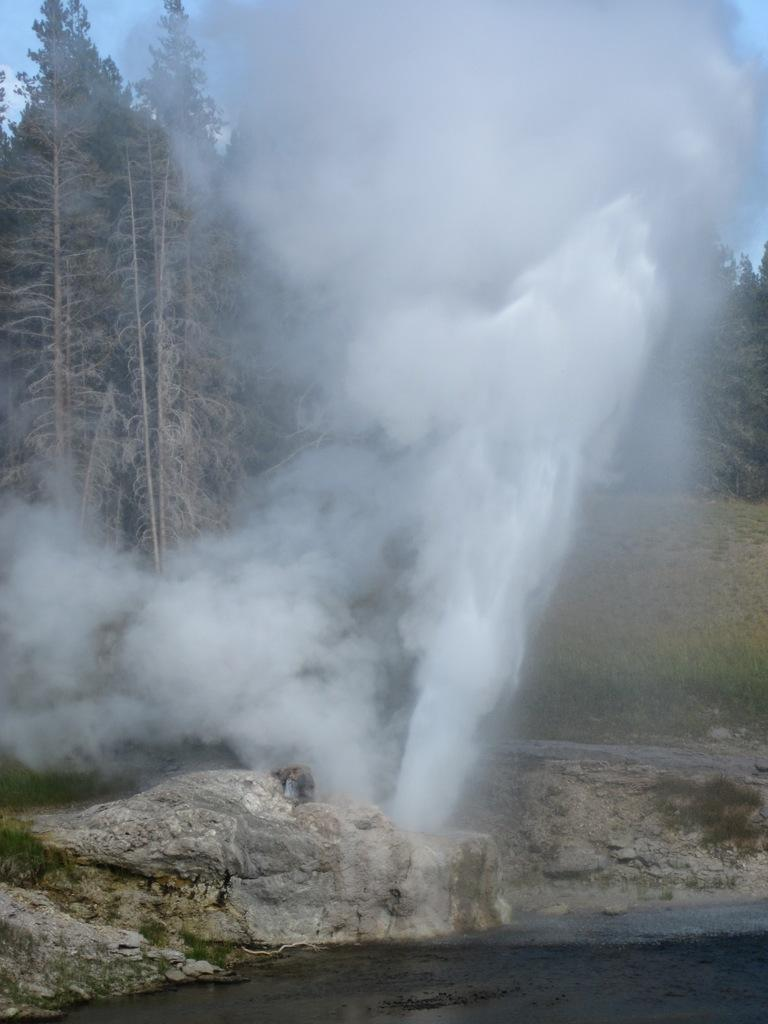What is the main feature of the image? The center of the image contains the sky. What type of vegetation can be seen in the image? Trees are present in the image. What is the ground surface like in the image? Grass is visible in the image. What other natural elements are present in the image? Rocks and water are in the image. What specific type of water feature is in the image? There is a hot spring in the image. What color is the tramp in the image? There is no tramp present in the image. How does the heat affect the silver objects in the image? There are no silver objects present in the image. 